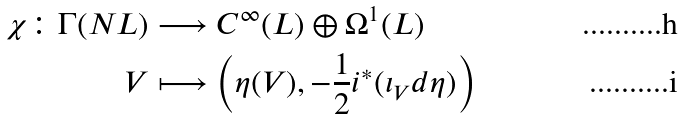<formula> <loc_0><loc_0><loc_500><loc_500>\chi \colon \Gamma ( N L ) & \longrightarrow C ^ { \infty } ( L ) \oplus \Omega ^ { 1 } ( L ) \\ V & \longmapsto \left ( \eta ( V ) , - \frac { 1 } { 2 } i ^ { * } ( \iota _ { V } d \eta ) \right )</formula> 